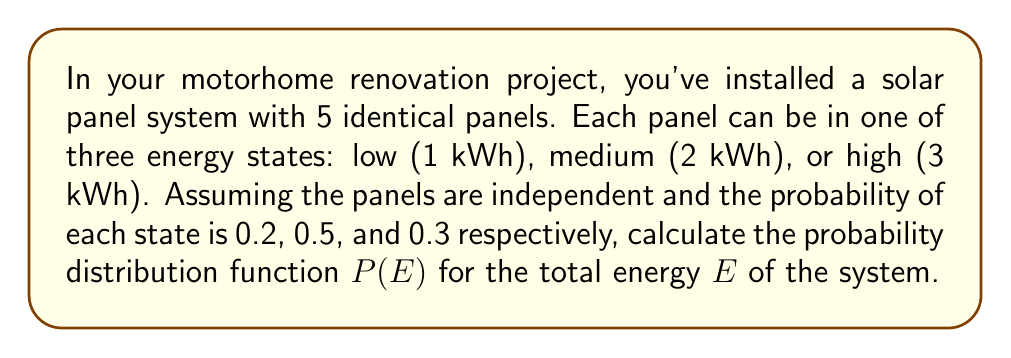Give your solution to this math problem. To solve this problem, we'll use concepts from statistical mechanics:

1) First, we need to identify the possible total energy levels. The minimum energy is 5 kWh (all panels in low state) and the maximum is 15 kWh (all panels in high state).

2) We can use the multinomial distribution to calculate the probability of each energy level. The probability of a specific configuration with $n_1$ panels in low state, $n_2$ in medium state, and $n_3$ in high state is:

   $$P(n_1,n_2,n_3) = \frac{5!}{n_1!n_2!n_3!} (0.2)^{n_1} (0.5)^{n_2} (0.3)^{n_3}$$

3) The total energy for a configuration is:

   $$E = 1n_1 + 2n_2 + 3n_3$$

4) We need to sum the probabilities of all configurations that give the same total energy. Here are the calculations for each possible energy level:

   For E = 5 kWh: (5,0,0) → P(5) = $\frac{5!}{5!0!0!}(0.2)^5 = 0.00032$

   For E = 6 kWh: (4,1,0) → P(6) = $\frac{5!}{4!1!0!}(0.2)^4(0.5)^1 = 0.00400$

   ...

   For E = 14 kWh: (0,1,4) → P(14) = $\frac{5!}{0!1!4!}(0.5)^1(0.3)^4 = 0.00405$

   For E = 15 kWh: (0,0,5) → P(15) = $\frac{5!}{0!0!5!}(0.3)^5 = 0.00243$

5) The complete probability distribution function $P(E)$ is the set of these probabilities for each energy level.
Answer: $P(E) = \{P(5)=0.00032, P(6)=0.00400, ..., P(14)=0.00405, P(15)=0.00243\}$ 